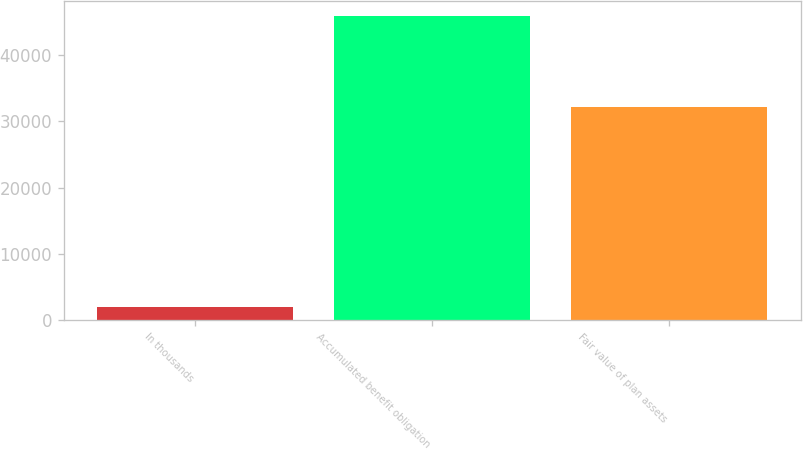<chart> <loc_0><loc_0><loc_500><loc_500><bar_chart><fcel>In thousands<fcel>Accumulated benefit obligation<fcel>Fair value of plan assets<nl><fcel>2008<fcel>45899<fcel>32164<nl></chart> 